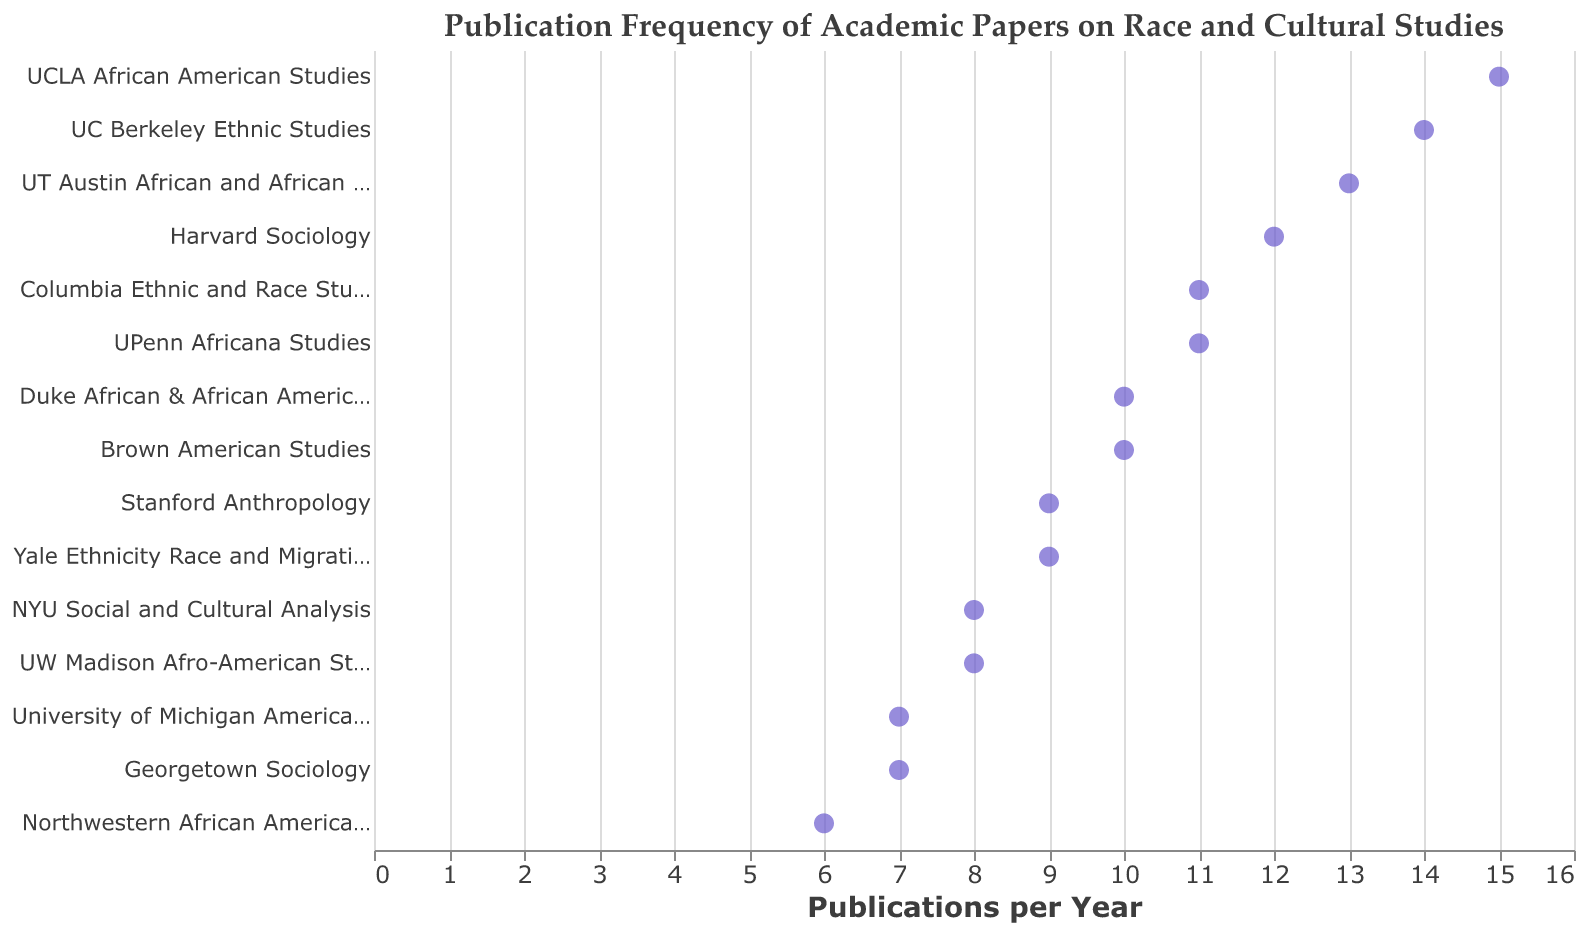How many departments have over 10 publications per year? Look at the figure and count the number of departments whose publication frequency is greater than 10, which are Harvard Sociology, UCLA African American Studies, Columbia Ethnic and Race Studies, UC Berkeley Ethnic Studies, UT Austin African and African Diaspora Studies, and UPenn Africana Studies.
Answer: 6 Which department has the highest number of publications per year? Identify the point farthest to the right on the x-axis, which corresponds to the highest publication frequency.
Answer: UCLA African American Studies What's the difference in publication frequency between the departments with the highest and lowest number of publications per year? Identify the department with the highest publications (UCLA African American Studies, 15) and the department with the lowest (Northwestern African American Studies, 6), then subtract the smaller number from the larger.
Answer: 9 Compare the publication frequencies of UC Berkeley Ethnic Studies and UT Austin African and African Diaspora Studies. Which is higher? Compare the position of the points for UC Berkeley Ethnic Studies (14) and UT Austin African and African Diaspora Studies (13) on the x-axis, and see which is more to the right.
Answer: UC Berkeley Ethnic Studies Which departments have exactly 9 publications per year? Look at the points at x = 9 and identify the corresponding departments: Stanford Anthropology and Yale Ethnicity Race and Migration.
Answer: Stanford Anthropology and Yale Ethnicity Race and Migration What is the median publication frequency of all the departments? List all publications per year values: 6, 7, 7, 8, 8, 9, 9, 10, 10, 11, 11, 12, 13, 14, 15. The middle value in the sorted list (15 values) is the 8th value.
Answer: 10 How many departments publish fewer than 10 papers per year? Count the number of points less than 10 on the x-axis: NYU Social and Cultural Analysis, University of Michigan American Culture, Northwestern African American Studies, UW Madison Afro-American Studies, Georgetown Sociology, Stanford Anthropology, and Yale Ethnicity Race and Migration.
Answer: 7 What is the average number of publications per year across all listed departments? Sum the publication frequencies for all departments (12+9+15+11+14+8+10+7+13+6+9+11+8+7+10) and divide by the number of departments (15). (12+9+15+11+14+8+10+7+13+6+9+11+8+7+10) / 15 = 141 / 15
Answer: 9.4 Identify two departments with the same number of publications per year. Look at the plot and identify departments with the same x-axis value. For example, UPenn Africana Studies and Columbia Ethnic and Race Studies both have 11 publications per year.
Answer: UPenn Africana Studies and Columbia Ethnic and Race Studies What trend or pattern is visible in the publication frequencies of these departments? Observe the general distribution of points. Many departments have publication frequencies clustering between 6 and 15, with a slight concentration around 9-11 publications per year.
Answer: Concentrated around 9-11 publications per year 